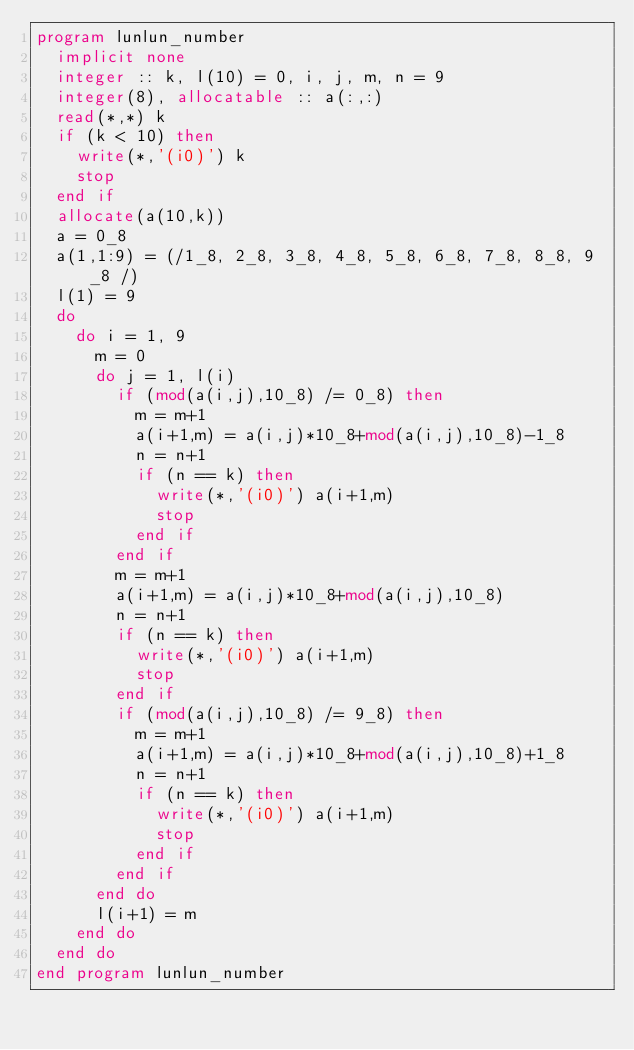<code> <loc_0><loc_0><loc_500><loc_500><_FORTRAN_>program lunlun_number
  implicit none
  integer :: k, l(10) = 0, i, j, m, n = 9
  integer(8), allocatable :: a(:,:)
  read(*,*) k
  if (k < 10) then
    write(*,'(i0)') k
    stop
  end if
  allocate(a(10,k))
  a = 0_8
  a(1,1:9) = (/1_8, 2_8, 3_8, 4_8, 5_8, 6_8, 7_8, 8_8, 9_8 /)
  l(1) = 9
  do
    do i = 1, 9
      m = 0
      do j = 1, l(i)
        if (mod(a(i,j),10_8) /= 0_8) then
          m = m+1
          a(i+1,m) = a(i,j)*10_8+mod(a(i,j),10_8)-1_8
          n = n+1
          if (n == k) then
            write(*,'(i0)') a(i+1,m)
            stop
          end if
        end if
        m = m+1
        a(i+1,m) = a(i,j)*10_8+mod(a(i,j),10_8)
        n = n+1
        if (n == k) then
          write(*,'(i0)') a(i+1,m)
          stop
        end if
        if (mod(a(i,j),10_8) /= 9_8) then
          m = m+1
          a(i+1,m) = a(i,j)*10_8+mod(a(i,j),10_8)+1_8
          n = n+1
          if (n == k) then
            write(*,'(i0)') a(i+1,m)
            stop
          end if
        end if
      end do
      l(i+1) = m
    end do
  end do
end program lunlun_number</code> 